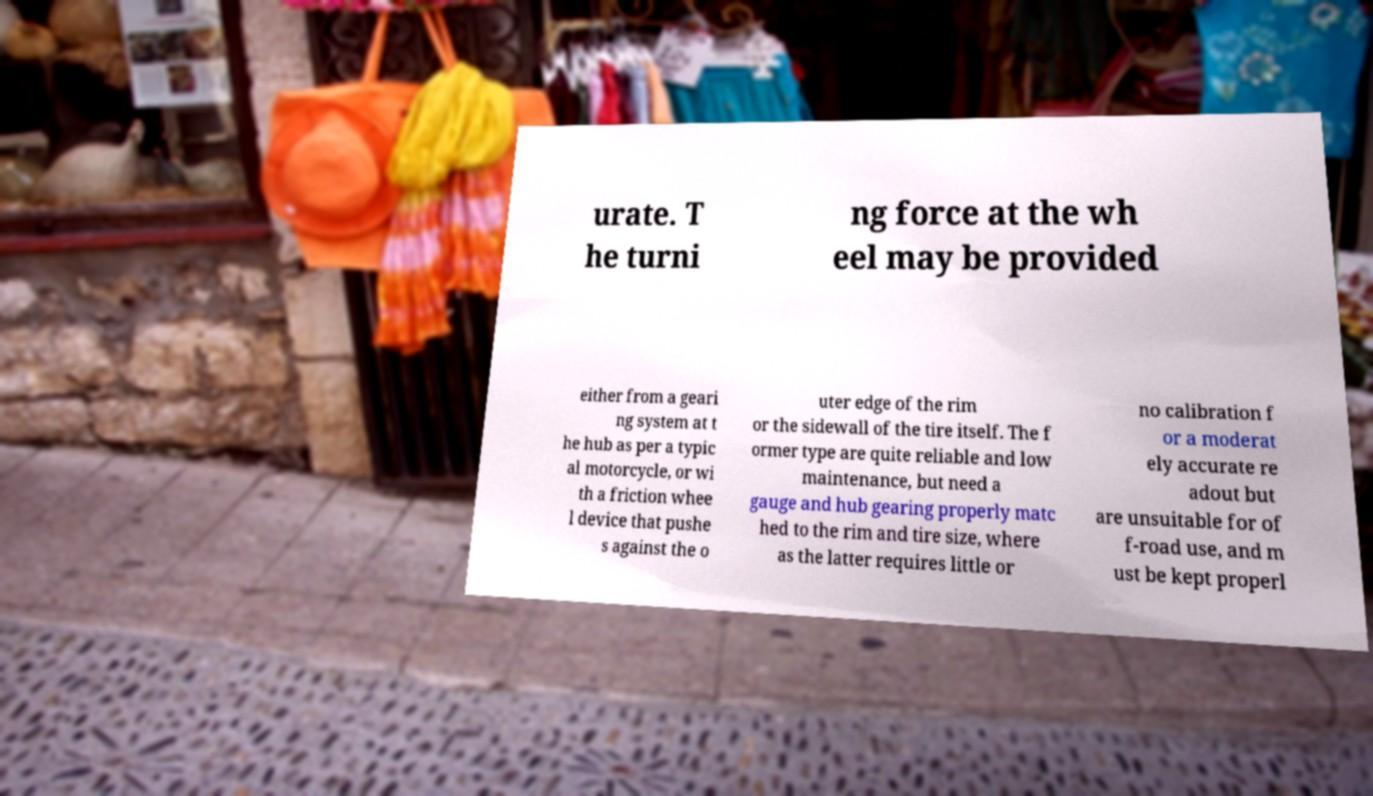Please identify and transcribe the text found in this image. urate. T he turni ng force at the wh eel may be provided either from a geari ng system at t he hub as per a typic al motorcycle, or wi th a friction whee l device that pushe s against the o uter edge of the rim or the sidewall of the tire itself. The f ormer type are quite reliable and low maintenance, but need a gauge and hub gearing properly matc hed to the rim and tire size, where as the latter requires little or no calibration f or a moderat ely accurate re adout but are unsuitable for of f-road use, and m ust be kept properl 